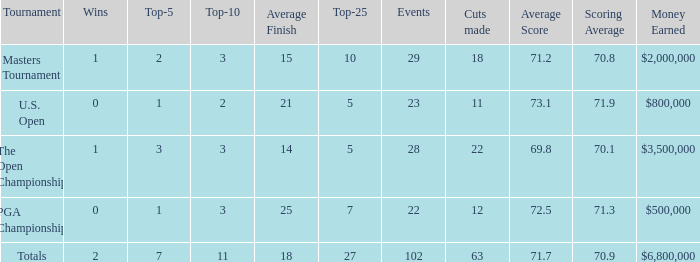How many top 10s associated with 3 top 5s and under 22 cuts made? None. Write the full table. {'header': ['Tournament', 'Wins', 'Top-5', 'Top-10', 'Average Finish', 'Top-25', 'Events', 'Cuts made', 'Average Score', 'Scoring Average', 'Money Earned'], 'rows': [['Masters Tournament', '1', '2', '3', '15', '10', '29', '18', '71.2', '70.8', '$2,000,000'], ['U.S. Open', '0', '1', '2', '21', '5', '23', '11', '73.1', '71.9', '$800,000'], ['The Open Championship', '1', '3', '3', '14', '5', '28', '22', '69.8', '70.1', '$3,500,000'], ['PGA Championship', '0', '1', '3', '25', '7', '22', '12', '72.5', '71.3', '$500,000'], ['Totals', '2', '7', '11', '18', '27', '102', '63', '71.7', '70.9', '$6,800,000']]} 